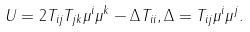<formula> <loc_0><loc_0><loc_500><loc_500>U = 2 T _ { i j } T _ { j k } \mu ^ { i } \mu ^ { k } - \Delta T _ { i i } , \Delta = T _ { i j } \mu ^ { i } \mu ^ { j } .</formula> 